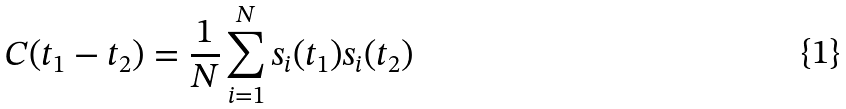<formula> <loc_0><loc_0><loc_500><loc_500>C ( t _ { 1 } - t _ { 2 } ) = \frac { 1 } { N } \sum _ { i = 1 } ^ { N } s _ { i } ( t _ { 1 } ) s _ { i } ( t _ { 2 } )</formula> 